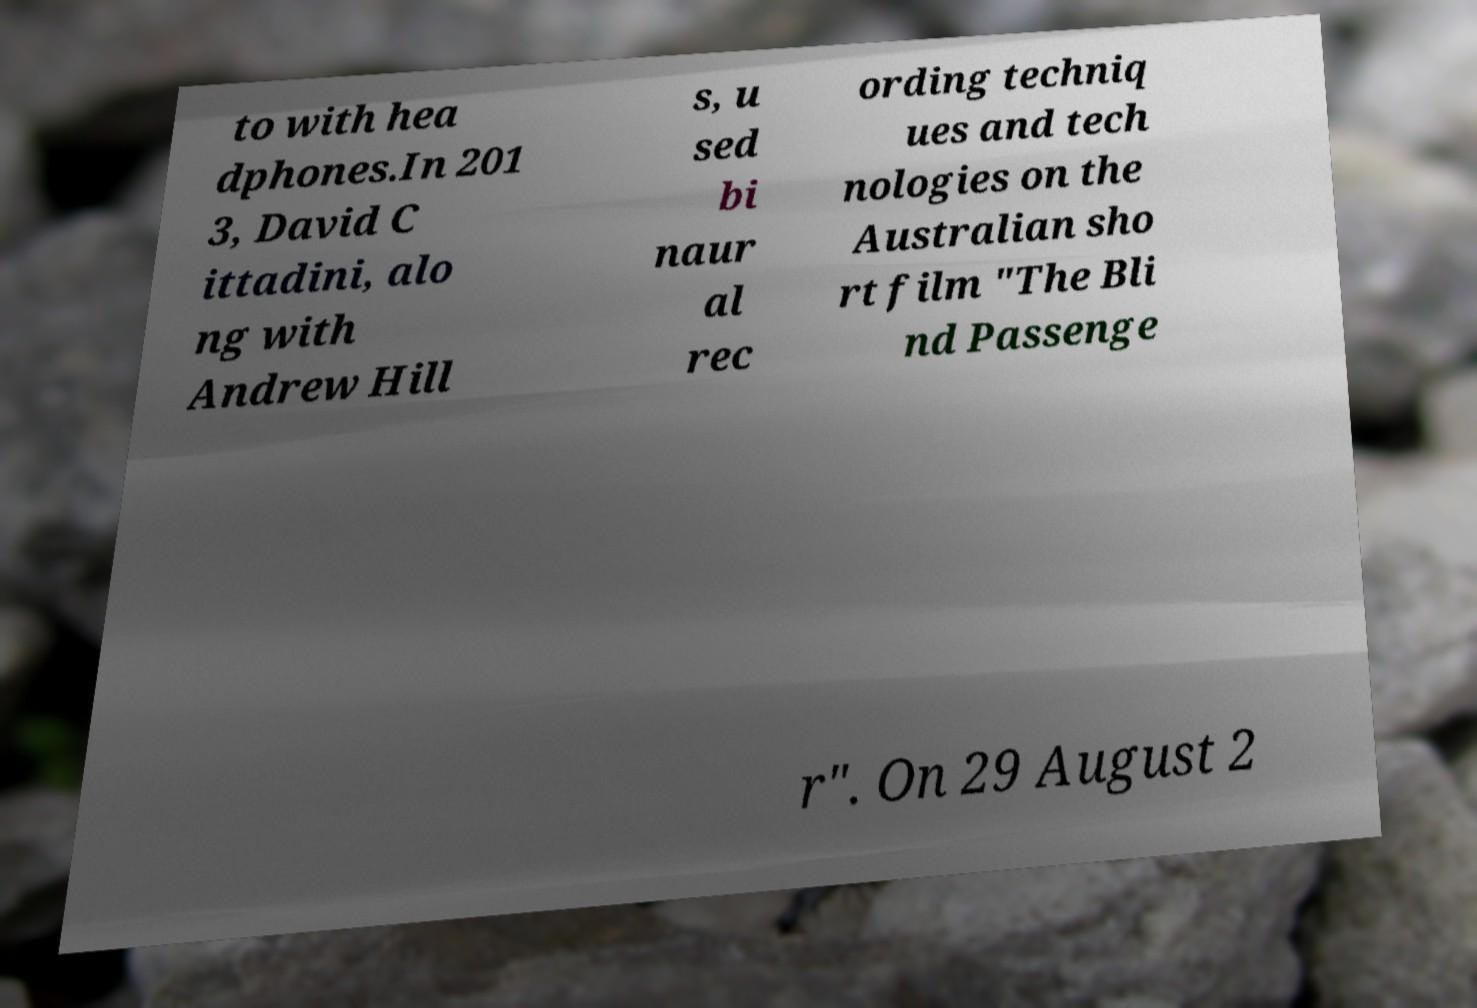Could you extract and type out the text from this image? to with hea dphones.In 201 3, David C ittadini, alo ng with Andrew Hill s, u sed bi naur al rec ording techniq ues and tech nologies on the Australian sho rt film "The Bli nd Passenge r". On 29 August 2 